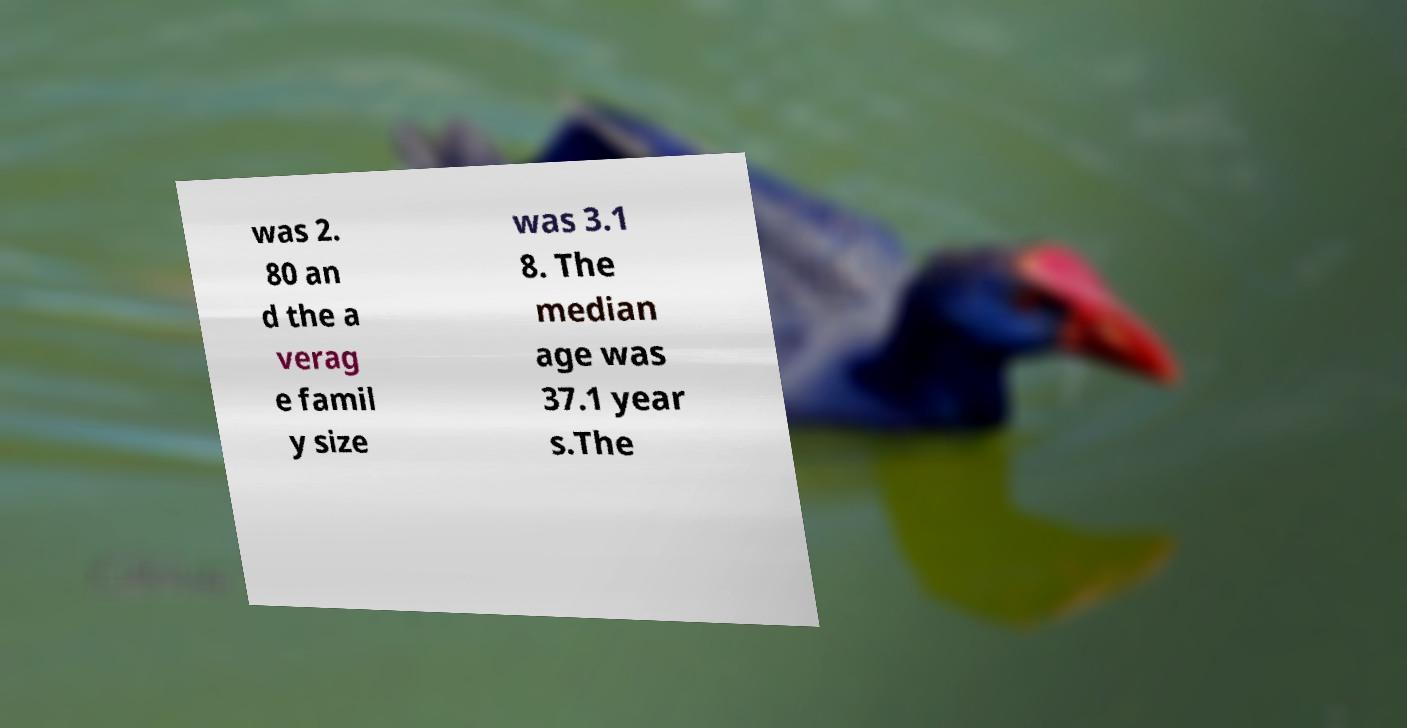For documentation purposes, I need the text within this image transcribed. Could you provide that? was 2. 80 an d the a verag e famil y size was 3.1 8. The median age was 37.1 year s.The 